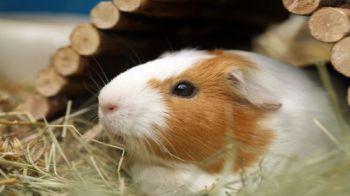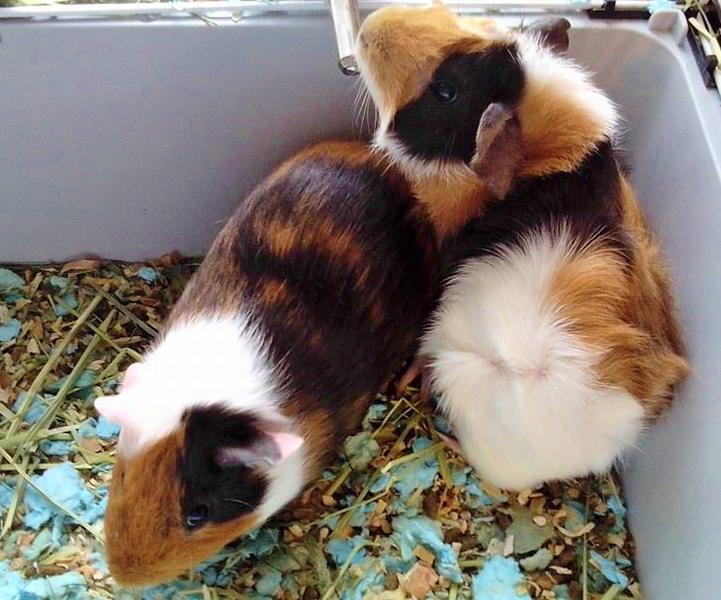The first image is the image on the left, the second image is the image on the right. For the images shown, is this caption "There are no more than two animals in a wire cage in one of the images." true? Answer yes or no. No. The first image is the image on the left, the second image is the image on the right. Considering the images on both sides, is "One image shows guinea pigs in the corner of an enclosure with plant matter on its floor, and the other image shows a guinea pig by a structure made of side-by-side wood rods." valid? Answer yes or no. Yes. 